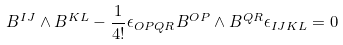Convert formula to latex. <formula><loc_0><loc_0><loc_500><loc_500>B ^ { I J } \wedge B ^ { K L } - \frac { 1 } { 4 ! } \epsilon _ { O P Q R } B ^ { O P } \wedge B ^ { Q R } \epsilon _ { I J K L } = 0</formula> 